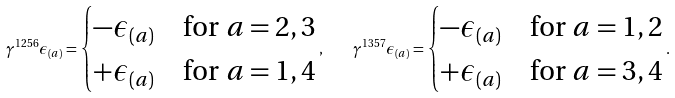Convert formula to latex. <formula><loc_0><loc_0><loc_500><loc_500>\gamma ^ { 1 2 5 6 } \epsilon _ { ( a ) } = \begin{cases} - \epsilon _ { ( a ) } & \text {for $a=2,3$} \\ + \epsilon _ { ( a ) } & \text {for $a=1,4$} \end{cases} , \quad \gamma ^ { 1 3 5 7 } \epsilon _ { ( a ) } = \begin{cases} - \epsilon _ { ( a ) } & \text {for $a=1,2$} \\ + \epsilon _ { ( a ) } & \text {for $a=3,4$} \end{cases} .</formula> 